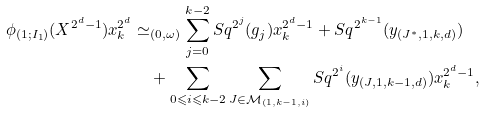Convert formula to latex. <formula><loc_0><loc_0><loc_500><loc_500>\phi _ { ( 1 ; I _ { 1 } ) } ( X ^ { 2 ^ { d } - 1 } ) x _ { k } ^ { 2 ^ { d } } & \simeq _ { ( 0 , \omega ) } \sum _ { j = 0 } ^ { k - 2 } S q ^ { 2 ^ { j } } ( g _ { j } ) x _ { k } ^ { 2 ^ { d } - 1 } + S q ^ { 2 ^ { k - 1 } } ( y _ { ( J ^ { * } , 1 , k , d ) } ) \\ & \quad + \sum _ { 0 \leqslant i \leqslant k - 2 } \sum _ { J \in \mathcal { M } _ { ( 1 , k - 1 , i ) } } S q ^ { 2 ^ { i } } ( y _ { ( J , 1 , k - 1 , d ) } ) x _ { k } ^ { 2 ^ { d } - 1 } ,</formula> 